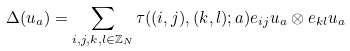Convert formula to latex. <formula><loc_0><loc_0><loc_500><loc_500>\Delta ( u _ { a } ) = \sum _ { i , j , k , l \in \mathbb { Z } _ { N } } \tau ( ( i , j ) , ( k , l ) ; a ) e _ { i j } u _ { a } \otimes e _ { k l } u _ { a }</formula> 